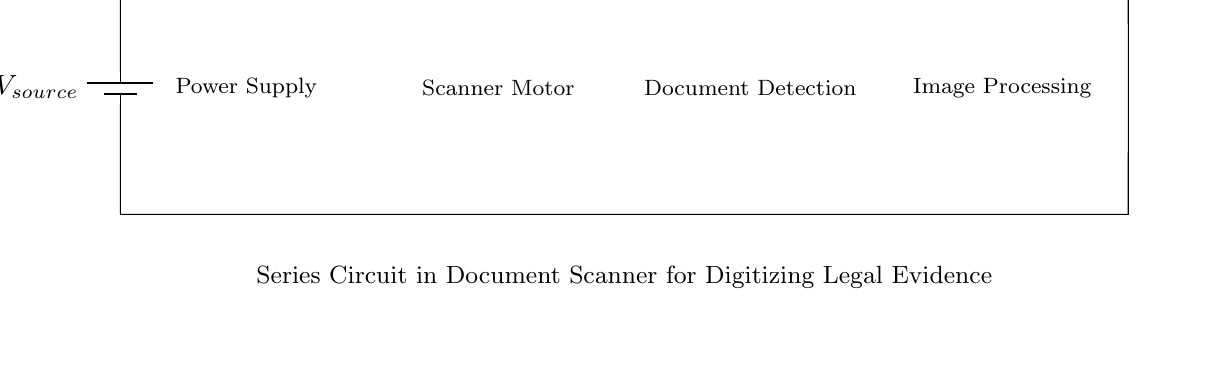What is the type of circuit shown? The circuit is a series circuit, as all components are connected end-to-end in a single path for the current.
Answer: Series circuit What is the primary function of the motor? The motor in the circuit is responsible for moving the document through the scanner for digitization.
Answer: Move documents What component would be responsible for detecting a document? The document sensor is specifically designed to detect the presence of a document in the scanner.
Answer: Document sensor What is the current flowing through the circuit labeled as? The current in this circuit is represented by the variable 'I', indicating the flow of electric charge through each component.
Answer: I Explain why all components must function for the scanner to work. In a series circuit, the current must flow through each component sequentially; if one component fails or is disconnected, the entire circuit is interrupted, and none of the components can operate.
Answer: All must function What role does the image processor play in this circuit? The image processor is responsible for converting scanned images into digital formats for storage or manipulation following the detection of a document.
Answer: Converts images 